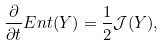<formula> <loc_0><loc_0><loc_500><loc_500>\frac { \partial } { \partial t } E n t ( Y ) = \frac { 1 } { 2 } \mathcal { J } ( Y ) ,</formula> 